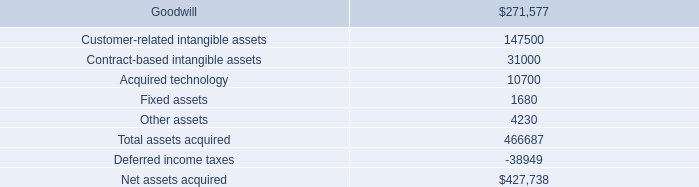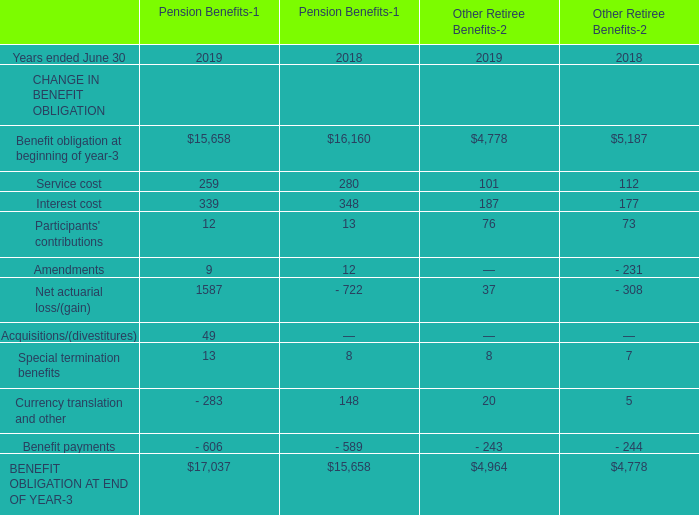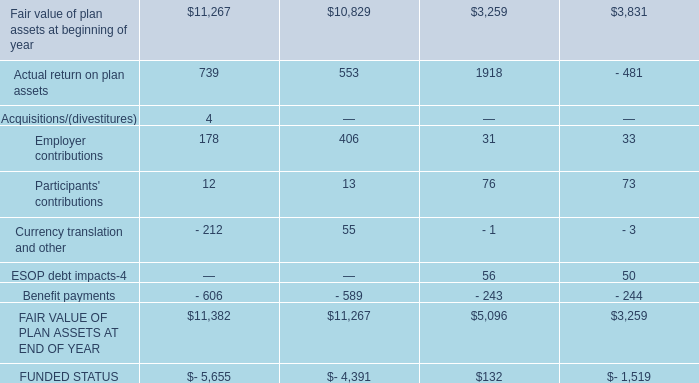What is the sum of the Net actuarial loss/(gain) in the years where Service cost is positive? 
Computations: (((1587 - 722) + 37) - 308)
Answer: 594.0. 